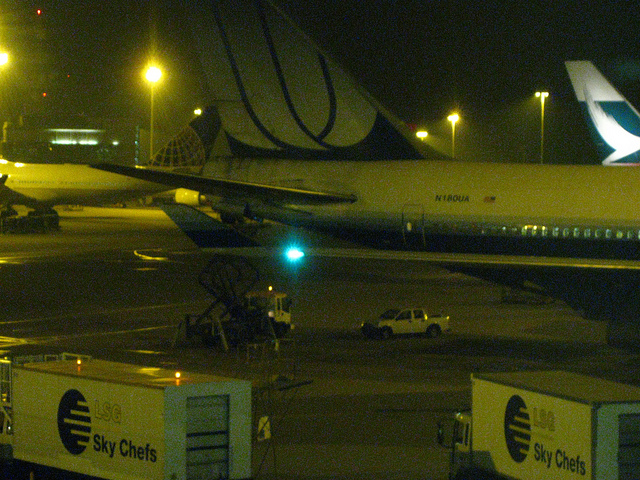Please extract the text content from this image. SKY Chefs LSG Sky CHEFS NNOUA 